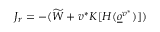Convert formula to latex. <formula><loc_0><loc_0><loc_500><loc_500>J _ { r } = - ( \widetilde { W } + v ^ { * } K [ H ( \underline { o } ^ { v ^ { * } } ) ] )</formula> 